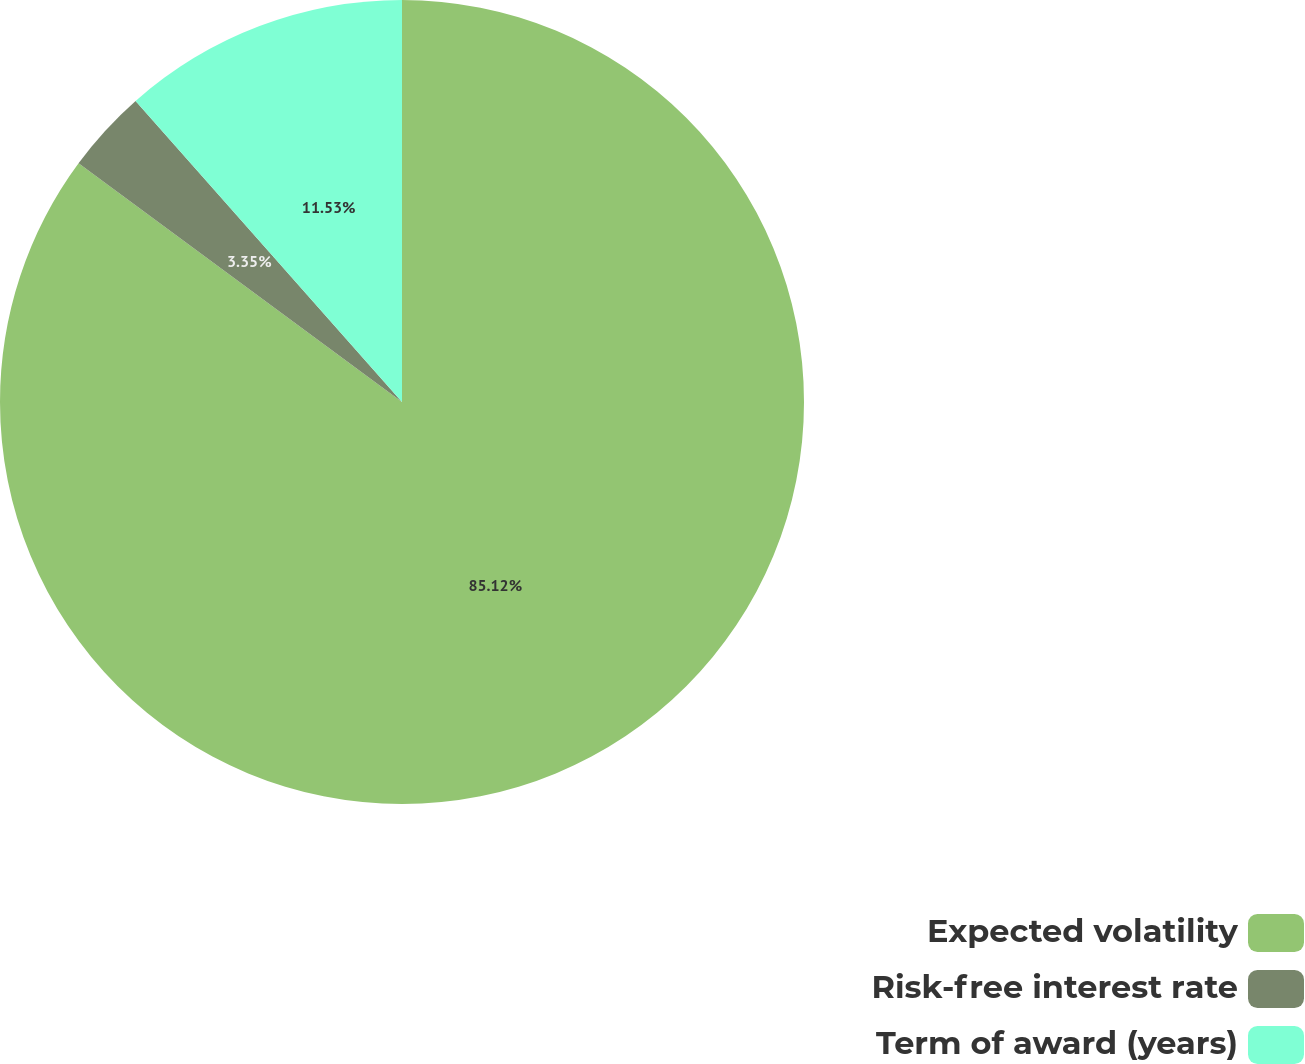Convert chart. <chart><loc_0><loc_0><loc_500><loc_500><pie_chart><fcel>Expected volatility<fcel>Risk-free interest rate<fcel>Term of award (years)<nl><fcel>85.12%<fcel>3.35%<fcel>11.53%<nl></chart> 